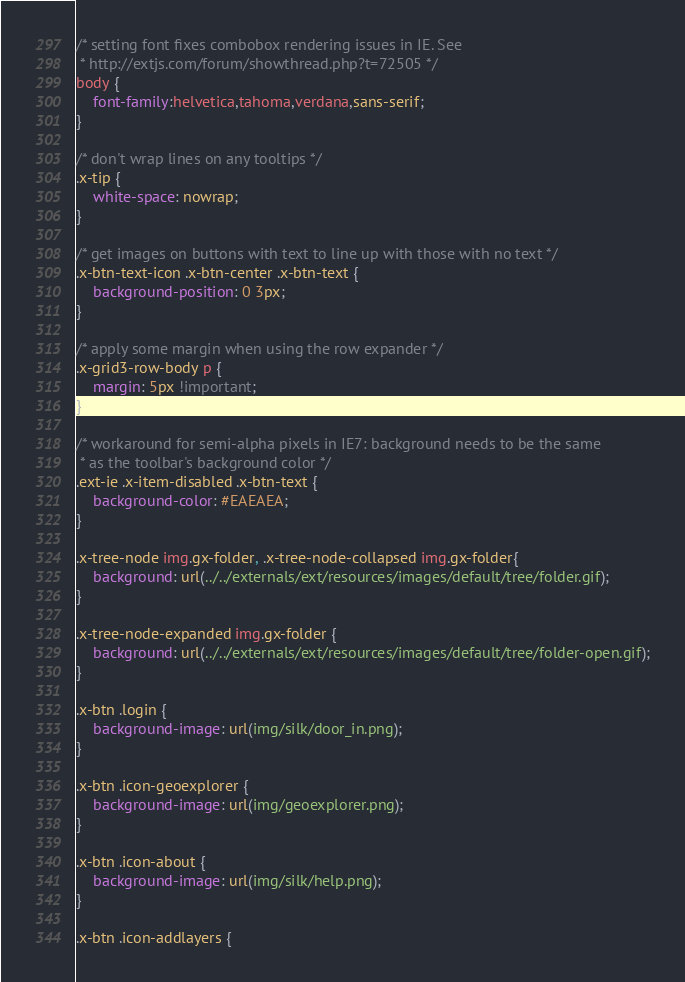Convert code to text. <code><loc_0><loc_0><loc_500><loc_500><_CSS_>/* setting font fixes combobox rendering issues in IE. See
 * http://extjs.com/forum/showthread.php?t=72505 */
body {
    font-family:helvetica,tahoma,verdana,sans-serif;
}

/* don't wrap lines on any tooltips */
.x-tip {
    white-space: nowrap;
}

/* get images on buttons with text to line up with those with no text */
.x-btn-text-icon .x-btn-center .x-btn-text {
    background-position: 0 3px;
}

/* apply some margin when using the row expander */
.x-grid3-row-body p {
    margin: 5px !important;
}

/* workaround for semi-alpha pixels in IE7: background needs to be the same
 * as the toolbar's background color */
.ext-ie .x-item-disabled .x-btn-text {
    background-color: #EAEAEA;
}

.x-tree-node img.gx-folder, .x-tree-node-collapsed img.gx-folder{
    background: url(../../externals/ext/resources/images/default/tree/folder.gif);
}
 
.x-tree-node-expanded img.gx-folder {
    background: url(../../externals/ext/resources/images/default/tree/folder-open.gif);
}

.x-btn .login {
    background-image: url(img/silk/door_in.png);
}

.x-btn .icon-geoexplorer {
    background-image: url(img/geoexplorer.png);
}

.x-btn .icon-about {
    background-image: url(img/silk/help.png);
}

.x-btn .icon-addlayers {</code> 